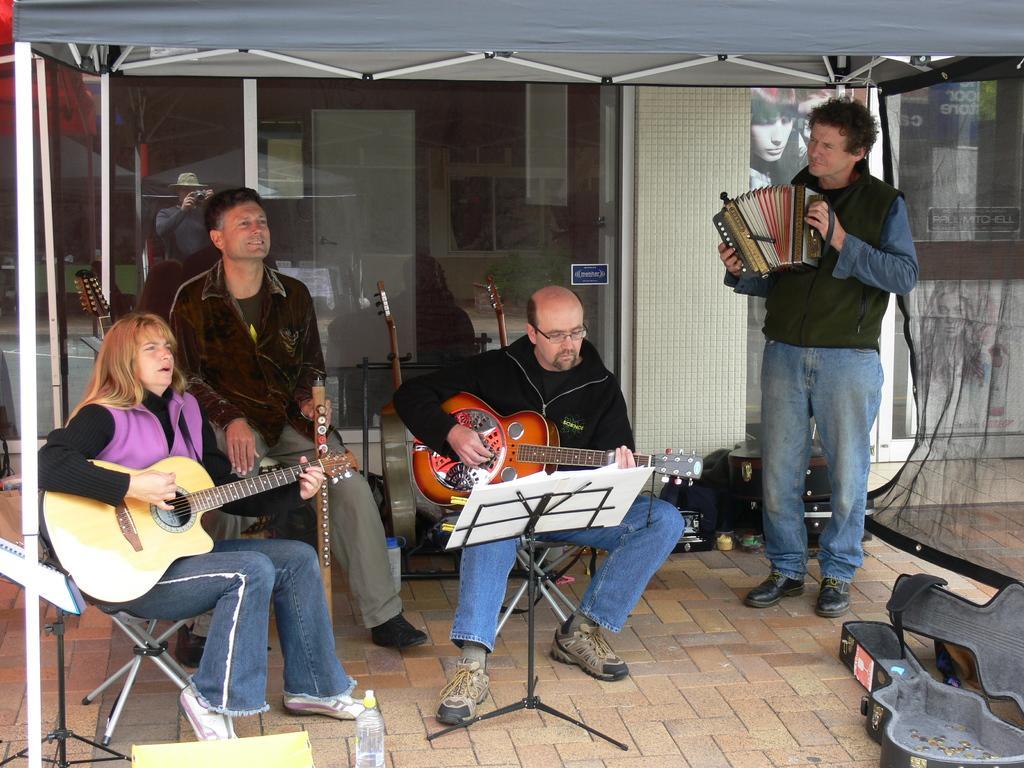Describe this image in one or two sentences. In this picture we can see two persons sitting on the chairs. They are playing guitar. Here we can see a man who is playing some musical instrument. This is floor and there is a bottle. On the background there is a glass. 